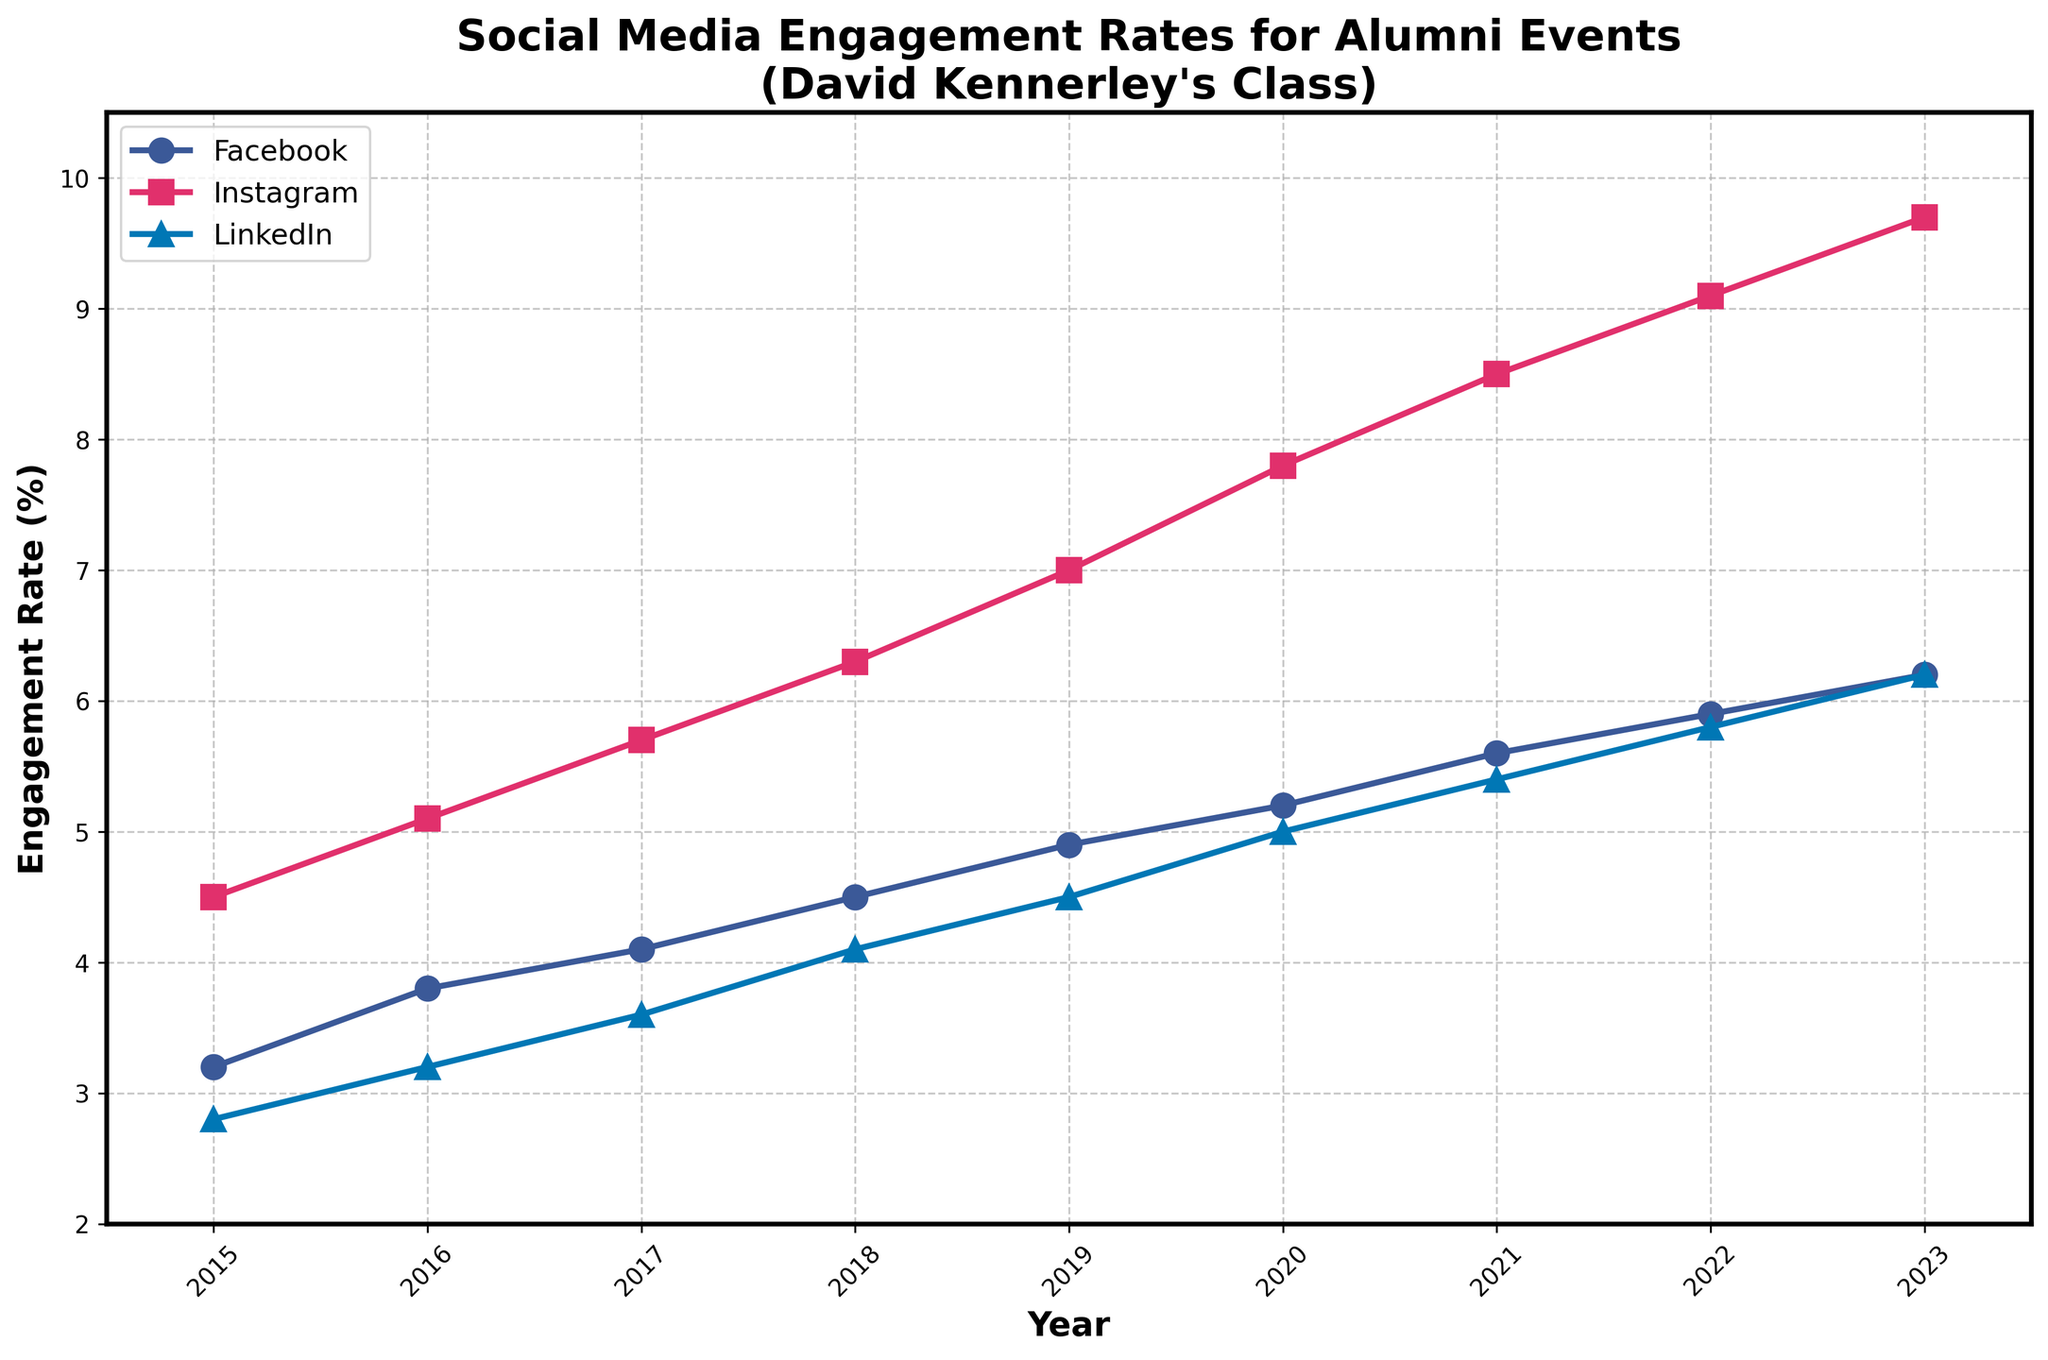Which social media platform had the highest engagement rate in 2023? In 2023, the Instagram engagement rate was highest as visually indicated by the topmost line.
Answer: Instagram By how much did the LinkedIn engagement rate increase from 2015 to 2023? Subtract the 2015 LinkedIn engagement rate (2.8%) from the 2023 LinkedIn engagement rate (6.2%). So, 6.2% - 2.8% = 3.4%.
Answer: 3.4% Is the increase in the Facebook engagement rate from 2015 to 2023 greater than that of Instagram? Calculate the difference in engagement rates for both: Facebook (6.2% - 3.2% = 3%) and Instagram (9.7% - 4.5% = 5.2%). Comparing the two, 3% is less than 5.2%.
Answer: No Which year saw the highest increase in Instagram engagement rate compared to the previous year? Find the year with the highest year-over-year difference: 2016 (5.1%-4.5%=0.6%), 2017 (5.7%-5.1%=0.6%), 2018 (6.3%-5.7%=0.6%), 2019 (7.0%-6.3%=0.7%), 2020 (7.8%-7.0%=0.8%), 2021 (8.5%-7.8%=0.7%), 2022 (9.1%-8.5%=0.6%), 2023 (9.7%-9.1%=0.6%). The highest increase is from 2019 to 2020 with 0.8%.
Answer: 2020 What was the average engagement rate for LinkedIn across all years? Sum all LinkedIn engagement rates and divide by the number of years: (2.8 + 3.2 + 3.6 + 4.1 + 4.5 + 5.0 + 5.4 + 5.8 + 6.2) / 9 = 4.4%.
Answer: 4.4% Compare the trend of Facebook and LinkedIn engagement rates from 2015 to 2023. Which shows a more consistent increase? Observe the overall slope of the lines; both increase, but Facebook's engagement rate shows a steadier and more consistent upward trajectory with no sudden changes, unlike LinkedIn.
Answer: Facebook In which year did Facebook and LinkedIn engagement rates both exceed 5% for the first time? Look for the first year when both rates exceed 5%: Facebook (2021: 5.6%), LinkedIn (2020: 5.0%). The first occurrence for both is in 2021.
Answer: 2021 What color represents Instagram engagement rate on the plot? Instagram engagement rate is depicted with the line colored in pink.
Answer: Pink 